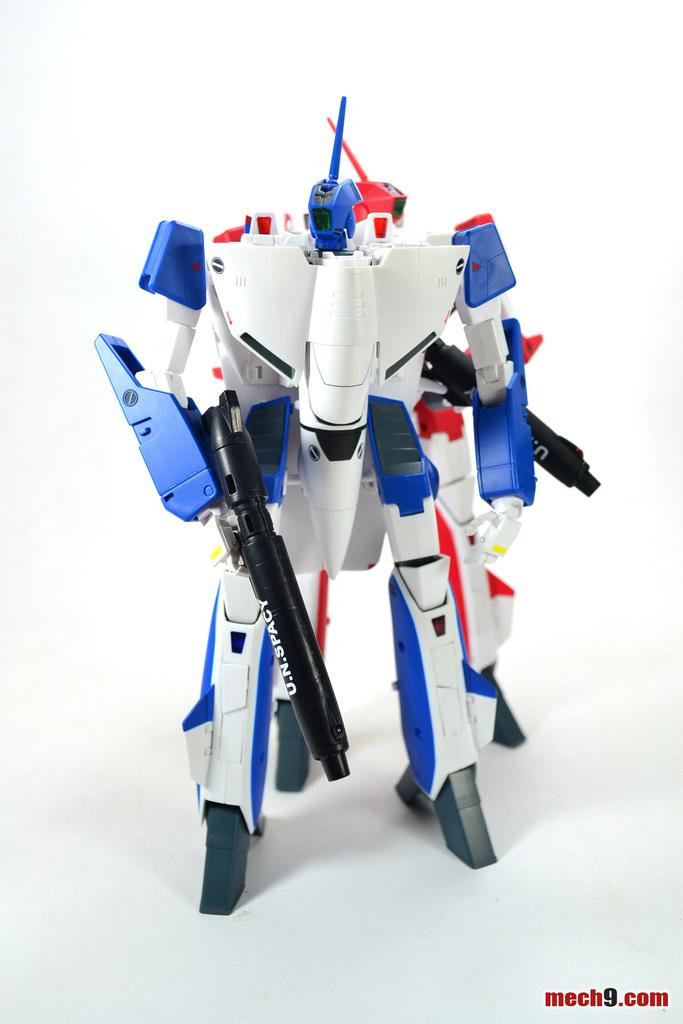What is the main subject of the image? There is a toy robot in the image. Can you describe the colors of the toy robot? The toy robot has black, blue, red, and white colors. What is the color of the surface the toy robot is on? The toy robot is on a white surface. Is there an afterthought bucket placed low in the image? There is no bucket or mention of an afterthought in the image; it only features a toy robot on a white surface. 